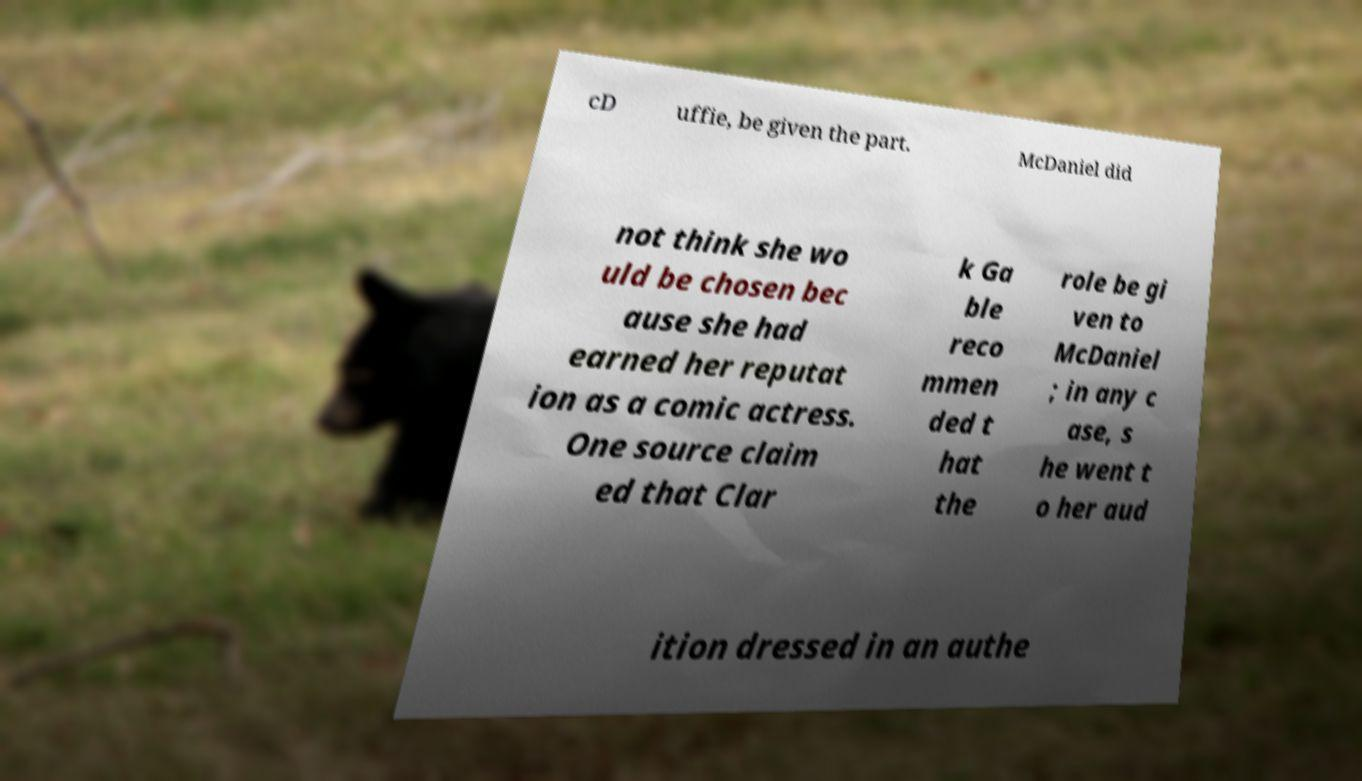Can you read and provide the text displayed in the image?This photo seems to have some interesting text. Can you extract and type it out for me? cD uffie, be given the part. McDaniel did not think she wo uld be chosen bec ause she had earned her reputat ion as a comic actress. One source claim ed that Clar k Ga ble reco mmen ded t hat the role be gi ven to McDaniel ; in any c ase, s he went t o her aud ition dressed in an authe 